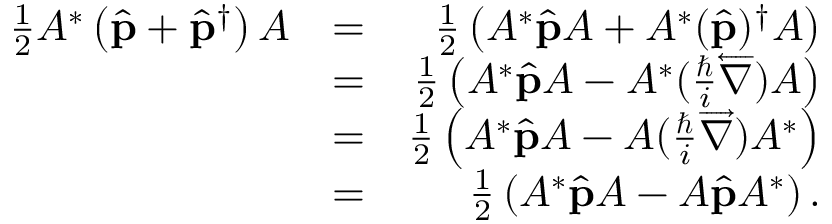Convert formula to latex. <formula><loc_0><loc_0><loc_500><loc_500>\begin{array} { r l r } { \frac { 1 } { 2 } A ^ { * } \left ( \hat { p } + \hat { p } ^ { \dagger } \right ) A } & { = } & { \frac { 1 } { 2 } \left ( A ^ { * } \hat { p } A + A ^ { * } ( \hat { p } ) ^ { \dagger } A \right ) } \\ & { = } & { \frac { 1 } { 2 } \left ( A ^ { * } \hat { p } A - A ^ { * } ( \frac { } { i } \overleftarrow { \nabla } ) A \right ) } \\ & { = } & { \frac { 1 } { 2 } \left ( A ^ { * } \hat { p } A - A ( \frac { } { i } \overrightarrow { \nabla } ) A ^ { * } \right ) } \\ & { = } & { \frac { 1 } { 2 } \left ( A ^ { * } \hat { p } A - A \hat { p } A ^ { * } \right ) . } \end{array}</formula> 